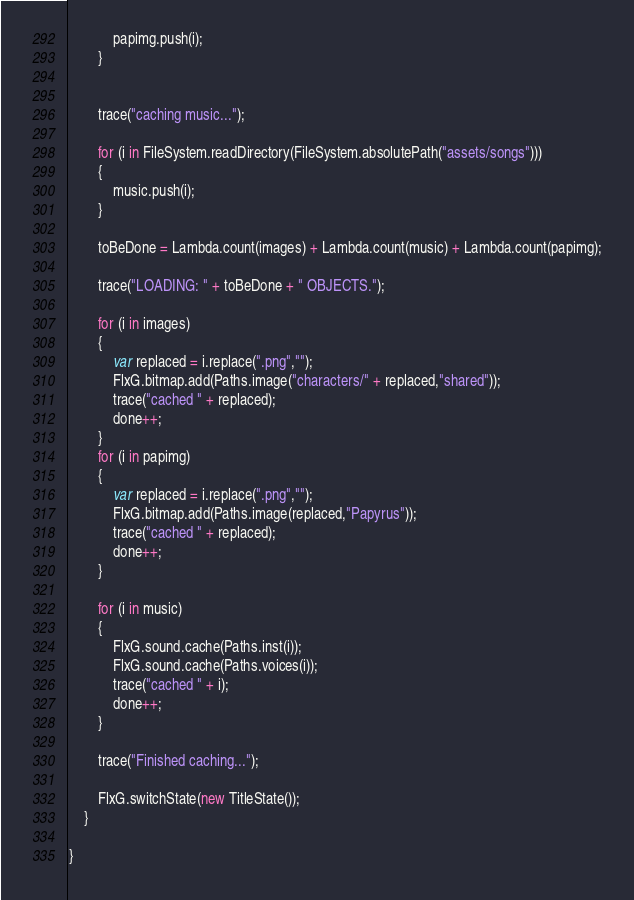<code> <loc_0><loc_0><loc_500><loc_500><_Haxe_>            papimg.push(i);
        }


        trace("caching music...");

        for (i in FileSystem.readDirectory(FileSystem.absolutePath("assets/songs")))
        {
            music.push(i);
        }

        toBeDone = Lambda.count(images) + Lambda.count(music) + Lambda.count(papimg);

        trace("LOADING: " + toBeDone + " OBJECTS.");

        for (i in images)
        {
            var replaced = i.replace(".png","");
            FlxG.bitmap.add(Paths.image("characters/" + replaced,"shared"));
            trace("cached " + replaced);
            done++;
        }
        for (i in papimg)
        {
            var replaced = i.replace(".png","");
            FlxG.bitmap.add(Paths.image(replaced,"Papyrus"));
            trace("cached " + replaced);
            done++;
        }

        for (i in music)
        {
            FlxG.sound.cache(Paths.inst(i));
            FlxG.sound.cache(Paths.voices(i));
            trace("cached " + i);
            done++;
        }

        trace("Finished caching...");

        FlxG.switchState(new TitleState());
    }

}</code> 